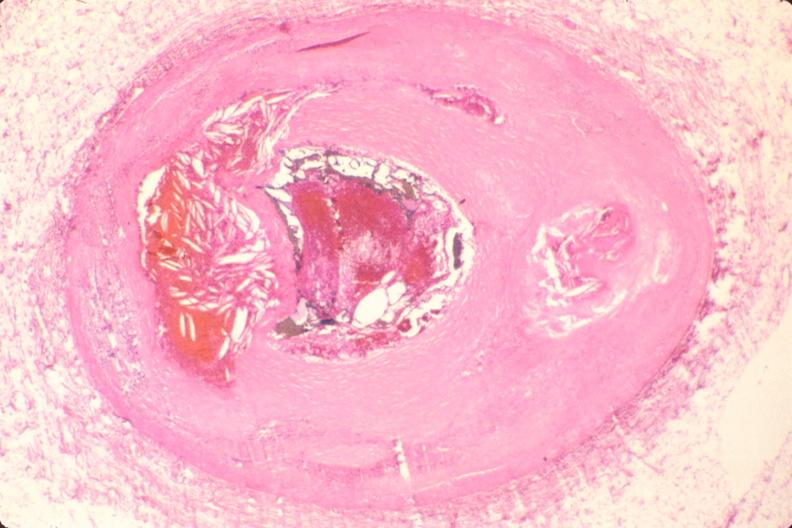where is this in?
Answer the question using a single word or phrase. In vasculature 